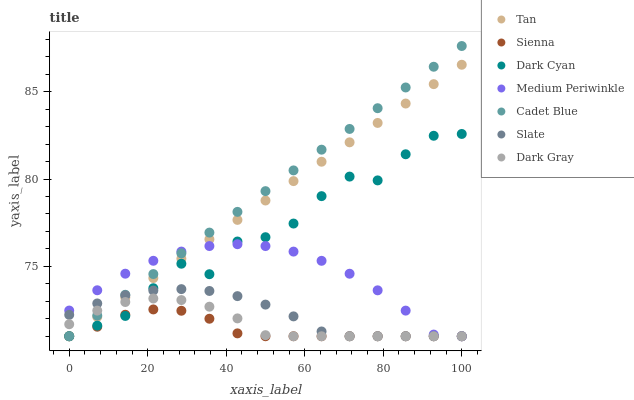Does Sienna have the minimum area under the curve?
Answer yes or no. Yes. Does Cadet Blue have the maximum area under the curve?
Answer yes or no. Yes. Does Slate have the minimum area under the curve?
Answer yes or no. No. Does Slate have the maximum area under the curve?
Answer yes or no. No. Is Cadet Blue the smoothest?
Answer yes or no. Yes. Is Dark Cyan the roughest?
Answer yes or no. Yes. Is Slate the smoothest?
Answer yes or no. No. Is Slate the roughest?
Answer yes or no. No. Does Dark Gray have the lowest value?
Answer yes or no. Yes. Does Cadet Blue have the highest value?
Answer yes or no. Yes. Does Slate have the highest value?
Answer yes or no. No. Does Tan intersect Dark Cyan?
Answer yes or no. Yes. Is Tan less than Dark Cyan?
Answer yes or no. No. Is Tan greater than Dark Cyan?
Answer yes or no. No. 